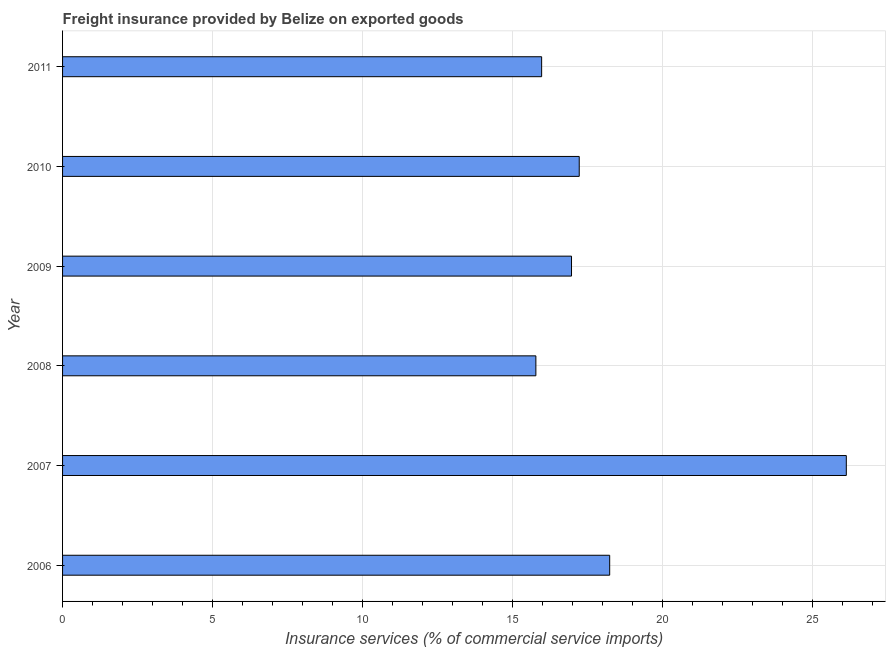What is the title of the graph?
Your answer should be very brief. Freight insurance provided by Belize on exported goods . What is the label or title of the X-axis?
Provide a short and direct response. Insurance services (% of commercial service imports). What is the freight insurance in 2009?
Provide a succinct answer. 16.97. Across all years, what is the maximum freight insurance?
Offer a terse response. 26.13. Across all years, what is the minimum freight insurance?
Your response must be concise. 15.78. In which year was the freight insurance minimum?
Your answer should be very brief. 2008. What is the sum of the freight insurance?
Your response must be concise. 110.3. What is the difference between the freight insurance in 2006 and 2007?
Make the answer very short. -7.89. What is the average freight insurance per year?
Provide a succinct answer. 18.38. What is the median freight insurance?
Offer a very short reply. 17.09. In how many years, is the freight insurance greater than 25 %?
Your response must be concise. 1. What is the ratio of the freight insurance in 2007 to that in 2011?
Provide a short and direct response. 1.64. What is the difference between the highest and the second highest freight insurance?
Provide a succinct answer. 7.89. Is the sum of the freight insurance in 2006 and 2009 greater than the maximum freight insurance across all years?
Make the answer very short. Yes. What is the difference between the highest and the lowest freight insurance?
Ensure brevity in your answer.  10.35. How many bars are there?
Your answer should be very brief. 6. Are all the bars in the graph horizontal?
Make the answer very short. Yes. What is the difference between two consecutive major ticks on the X-axis?
Provide a succinct answer. 5. What is the Insurance services (% of commercial service imports) in 2006?
Offer a terse response. 18.24. What is the Insurance services (% of commercial service imports) of 2007?
Your response must be concise. 26.13. What is the Insurance services (% of commercial service imports) in 2008?
Provide a succinct answer. 15.78. What is the Insurance services (% of commercial service imports) in 2009?
Your answer should be very brief. 16.97. What is the Insurance services (% of commercial service imports) in 2010?
Make the answer very short. 17.22. What is the Insurance services (% of commercial service imports) in 2011?
Keep it short and to the point. 15.97. What is the difference between the Insurance services (% of commercial service imports) in 2006 and 2007?
Give a very brief answer. -7.89. What is the difference between the Insurance services (% of commercial service imports) in 2006 and 2008?
Give a very brief answer. 2.46. What is the difference between the Insurance services (% of commercial service imports) in 2006 and 2009?
Make the answer very short. 1.27. What is the difference between the Insurance services (% of commercial service imports) in 2006 and 2010?
Offer a terse response. 1.02. What is the difference between the Insurance services (% of commercial service imports) in 2006 and 2011?
Ensure brevity in your answer.  2.27. What is the difference between the Insurance services (% of commercial service imports) in 2007 and 2008?
Make the answer very short. 10.35. What is the difference between the Insurance services (% of commercial service imports) in 2007 and 2009?
Give a very brief answer. 9.16. What is the difference between the Insurance services (% of commercial service imports) in 2007 and 2010?
Your response must be concise. 8.9. What is the difference between the Insurance services (% of commercial service imports) in 2007 and 2011?
Ensure brevity in your answer.  10.16. What is the difference between the Insurance services (% of commercial service imports) in 2008 and 2009?
Provide a succinct answer. -1.19. What is the difference between the Insurance services (% of commercial service imports) in 2008 and 2010?
Offer a very short reply. -1.45. What is the difference between the Insurance services (% of commercial service imports) in 2008 and 2011?
Offer a terse response. -0.19. What is the difference between the Insurance services (% of commercial service imports) in 2009 and 2010?
Keep it short and to the point. -0.26. What is the difference between the Insurance services (% of commercial service imports) in 2009 and 2011?
Give a very brief answer. 1. What is the difference between the Insurance services (% of commercial service imports) in 2010 and 2011?
Give a very brief answer. 1.25. What is the ratio of the Insurance services (% of commercial service imports) in 2006 to that in 2007?
Make the answer very short. 0.7. What is the ratio of the Insurance services (% of commercial service imports) in 2006 to that in 2008?
Ensure brevity in your answer.  1.16. What is the ratio of the Insurance services (% of commercial service imports) in 2006 to that in 2009?
Make the answer very short. 1.07. What is the ratio of the Insurance services (% of commercial service imports) in 2006 to that in 2010?
Keep it short and to the point. 1.06. What is the ratio of the Insurance services (% of commercial service imports) in 2006 to that in 2011?
Your answer should be compact. 1.14. What is the ratio of the Insurance services (% of commercial service imports) in 2007 to that in 2008?
Provide a succinct answer. 1.66. What is the ratio of the Insurance services (% of commercial service imports) in 2007 to that in 2009?
Ensure brevity in your answer.  1.54. What is the ratio of the Insurance services (% of commercial service imports) in 2007 to that in 2010?
Ensure brevity in your answer.  1.52. What is the ratio of the Insurance services (% of commercial service imports) in 2007 to that in 2011?
Offer a very short reply. 1.64. What is the ratio of the Insurance services (% of commercial service imports) in 2008 to that in 2010?
Make the answer very short. 0.92. What is the ratio of the Insurance services (% of commercial service imports) in 2009 to that in 2011?
Keep it short and to the point. 1.06. What is the ratio of the Insurance services (% of commercial service imports) in 2010 to that in 2011?
Provide a succinct answer. 1.08. 